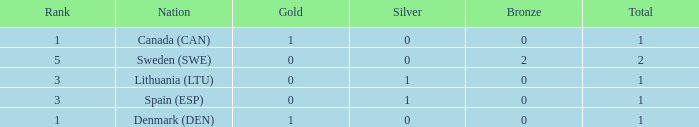What is the total when there were less than 0 bronze? 0.0. 